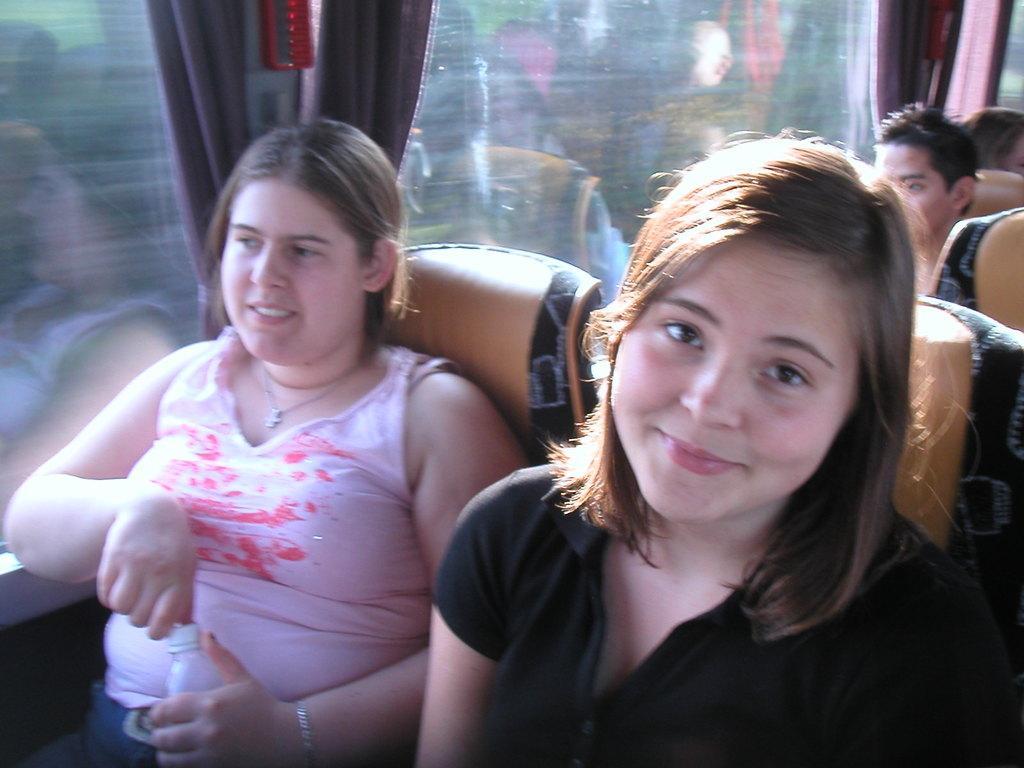Can you describe this image briefly? In front of the image there are two women sitting in the seats of a bus, behind them there are a few other people, beside them there are curtains on the glass windows, the woman is holding a bottle in her hand. 